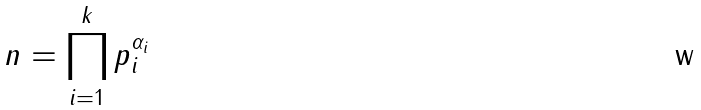<formula> <loc_0><loc_0><loc_500><loc_500>n = \prod _ { i = 1 } ^ { k } p _ { i } ^ { \alpha _ { i } }</formula> 